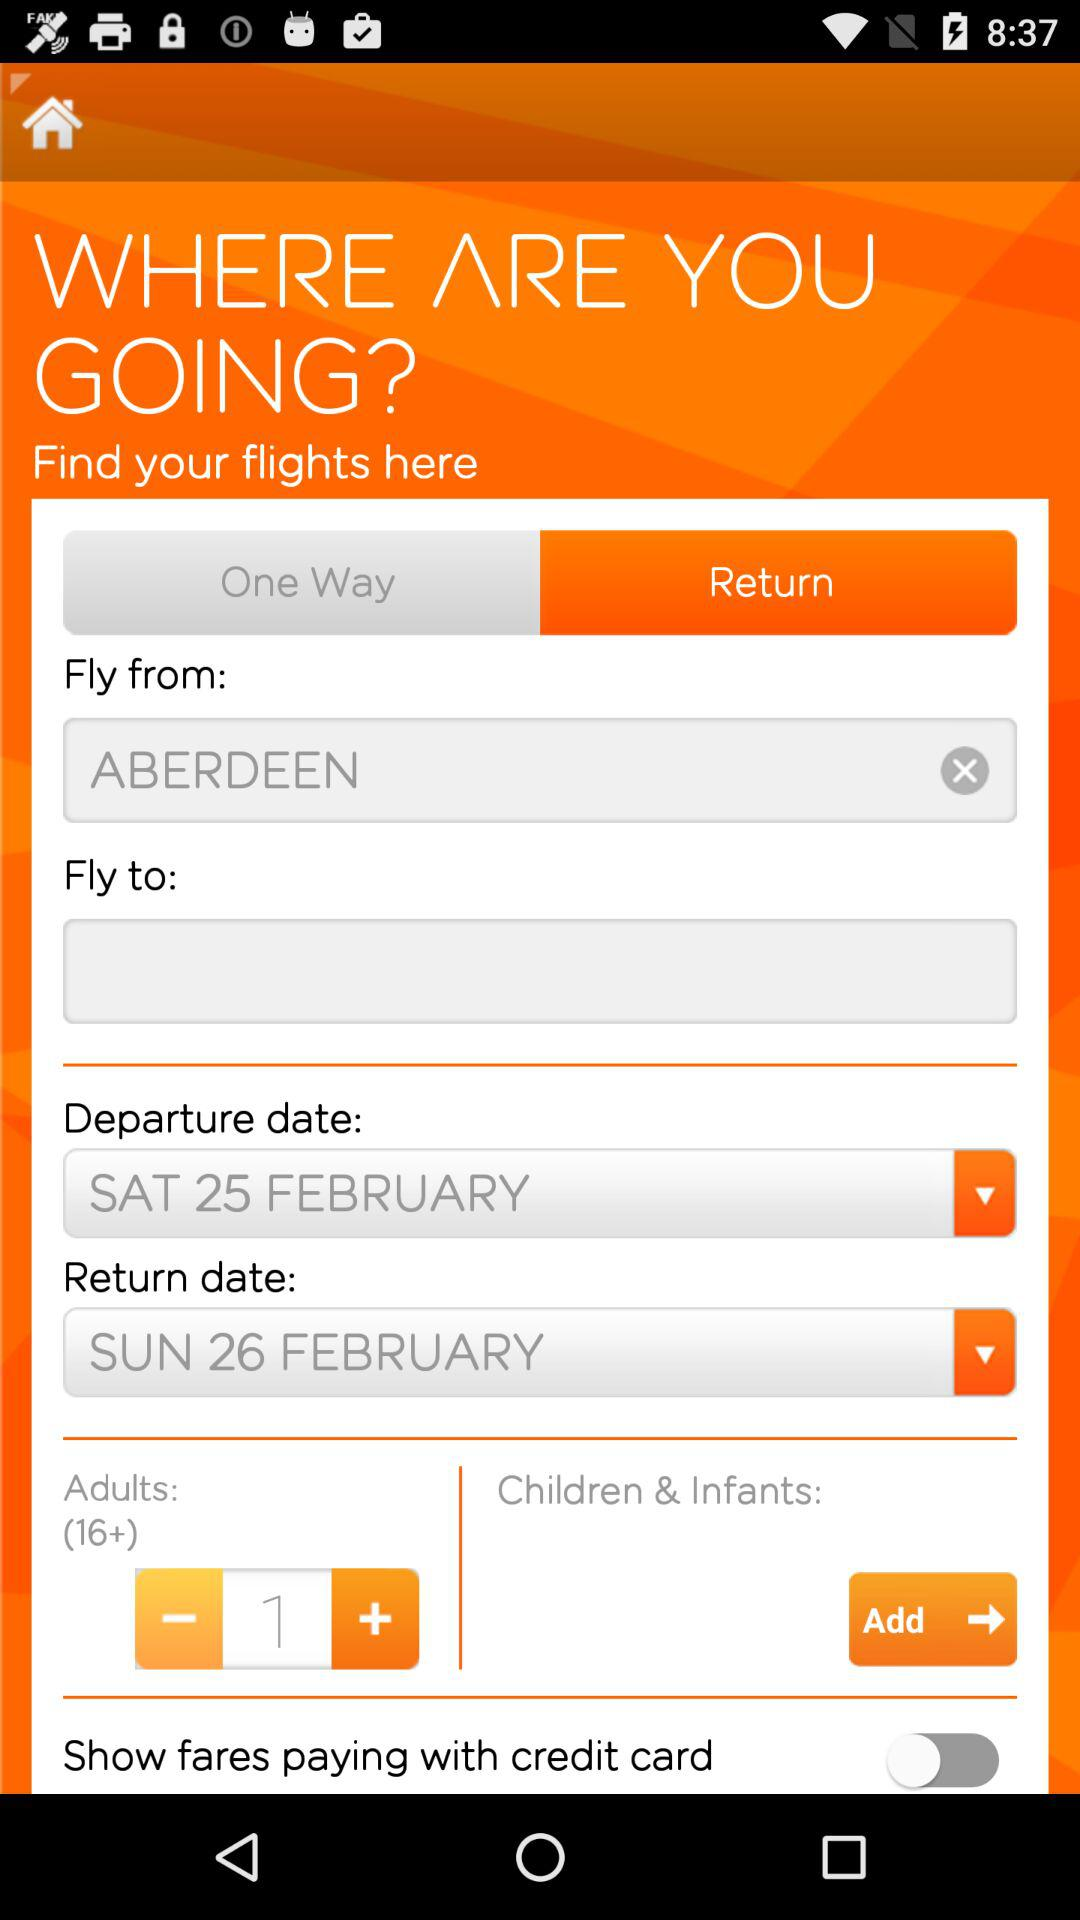What is the departure location? The departure location is Aberdeen. 